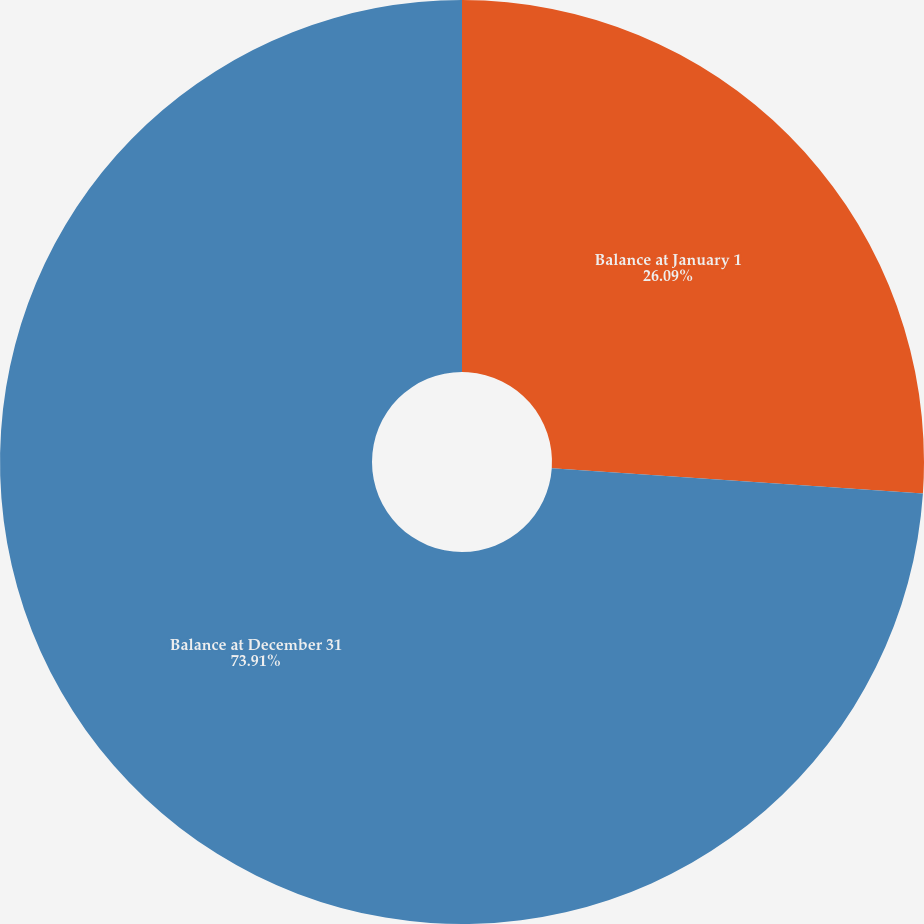Convert chart to OTSL. <chart><loc_0><loc_0><loc_500><loc_500><pie_chart><fcel>Balance at January 1<fcel>Balance at December 31<nl><fcel>26.09%<fcel>73.91%<nl></chart> 